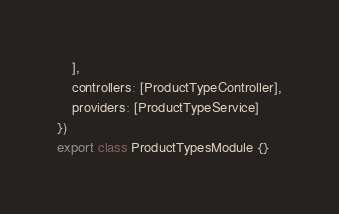<code> <loc_0><loc_0><loc_500><loc_500><_TypeScript_>	],
	controllers: [ProductTypeController],
	providers: [ProductTypeService]
})
export class ProductTypesModule {}
</code> 